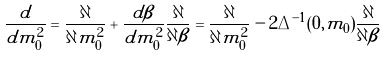<formula> <loc_0><loc_0><loc_500><loc_500>\frac { d } { d m _ { 0 } ^ { 2 } } = \frac { \partial } { \partial m _ { 0 } ^ { 2 } } + \frac { d \beta } { d m _ { 0 } ^ { 2 } } \frac { \partial } { \partial \beta } = \frac { \partial } { \partial m _ { 0 } ^ { 2 } } - 2 \Delta ^ { - 1 } ( 0 , m _ { 0 } ) \frac { \partial } { \partial \beta }</formula> 